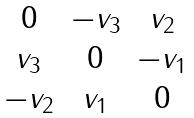Convert formula to latex. <formula><loc_0><loc_0><loc_500><loc_500>\begin{matrix} 0 & - v _ { 3 } & v _ { 2 } \\ v _ { 3 } & 0 & - v _ { 1 } \\ - v _ { 2 } & v _ { 1 } & 0 \end{matrix}</formula> 